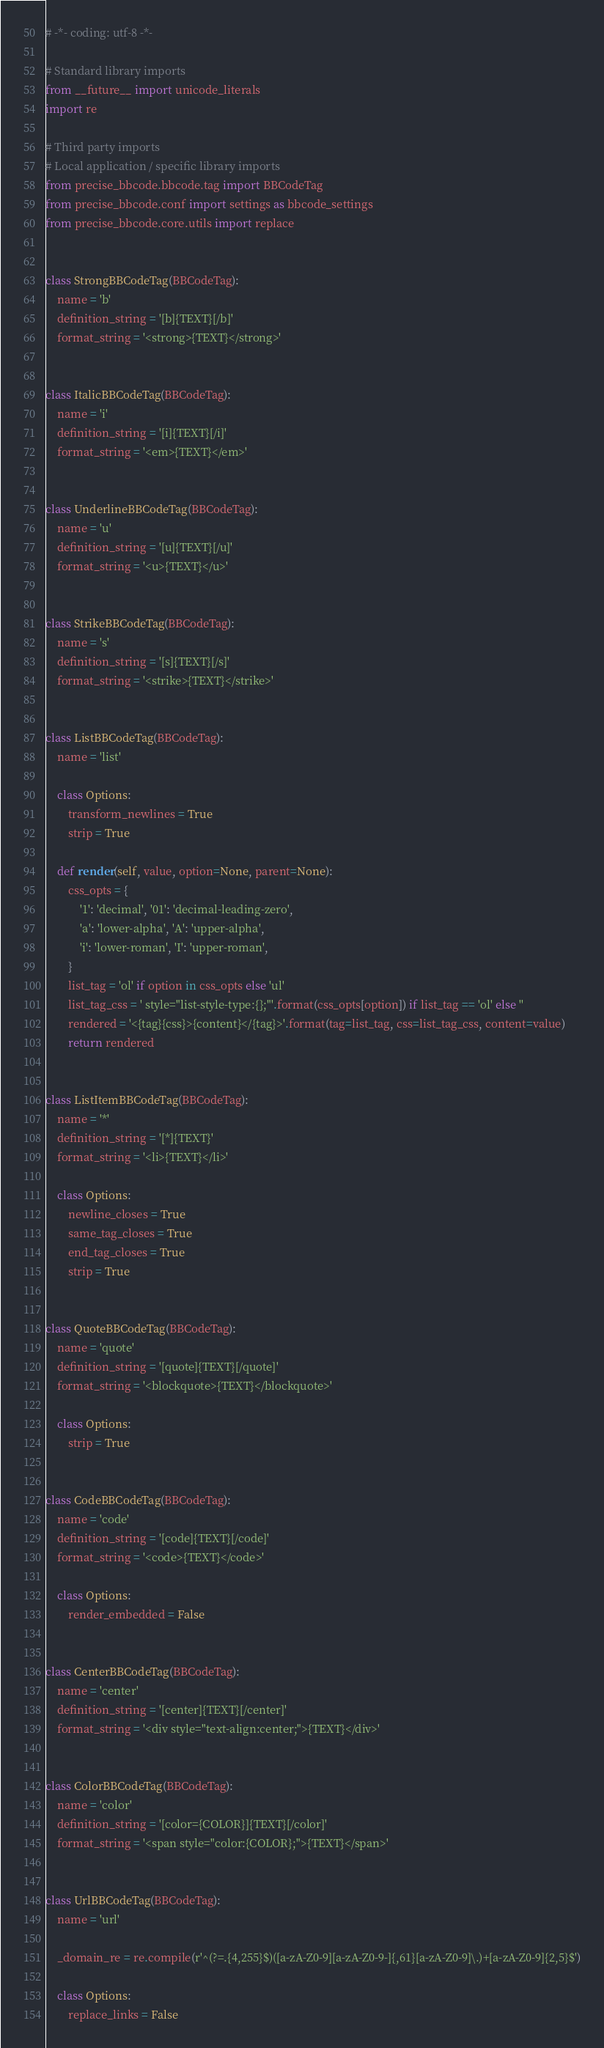<code> <loc_0><loc_0><loc_500><loc_500><_Python_># -*- coding: utf-8 -*-

# Standard library imports
from __future__ import unicode_literals
import re

# Third party imports
# Local application / specific library imports
from precise_bbcode.bbcode.tag import BBCodeTag
from precise_bbcode.conf import settings as bbcode_settings
from precise_bbcode.core.utils import replace


class StrongBBCodeTag(BBCodeTag):
    name = 'b'
    definition_string = '[b]{TEXT}[/b]'
    format_string = '<strong>{TEXT}</strong>'


class ItalicBBCodeTag(BBCodeTag):
    name = 'i'
    definition_string = '[i]{TEXT}[/i]'
    format_string = '<em>{TEXT}</em>'


class UnderlineBBCodeTag(BBCodeTag):
    name = 'u'
    definition_string = '[u]{TEXT}[/u]'
    format_string = '<u>{TEXT}</u>'


class StrikeBBCodeTag(BBCodeTag):
    name = 's'
    definition_string = '[s]{TEXT}[/s]'
    format_string = '<strike>{TEXT}</strike>'


class ListBBCodeTag(BBCodeTag):
    name = 'list'

    class Options:
        transform_newlines = True
        strip = True

    def render(self, value, option=None, parent=None):
        css_opts = {
            '1': 'decimal', '01': 'decimal-leading-zero',
            'a': 'lower-alpha', 'A': 'upper-alpha',
            'i': 'lower-roman', 'I': 'upper-roman',
        }
        list_tag = 'ol' if option in css_opts else 'ul'
        list_tag_css = ' style="list-style-type:{};"'.format(css_opts[option]) if list_tag == 'ol' else ''
        rendered = '<{tag}{css}>{content}</{tag}>'.format(tag=list_tag, css=list_tag_css, content=value)
        return rendered


class ListItemBBCodeTag(BBCodeTag):
    name = '*'
    definition_string = '[*]{TEXT}'
    format_string = '<li>{TEXT}</li>'

    class Options:
        newline_closes = True
        same_tag_closes = True
        end_tag_closes = True
        strip = True


class QuoteBBCodeTag(BBCodeTag):
    name = 'quote'
    definition_string = '[quote]{TEXT}[/quote]'
    format_string = '<blockquote>{TEXT}</blockquote>'

    class Options:
        strip = True


class CodeBBCodeTag(BBCodeTag):
    name = 'code'
    definition_string = '[code]{TEXT}[/code]'
    format_string = '<code>{TEXT}</code>'

    class Options:
        render_embedded = False


class CenterBBCodeTag(BBCodeTag):
    name = 'center'
    definition_string = '[center]{TEXT}[/center]'
    format_string = '<div style="text-align:center;">{TEXT}</div>'


class ColorBBCodeTag(BBCodeTag):
    name = 'color'
    definition_string = '[color={COLOR}]{TEXT}[/color]'
    format_string = '<span style="color:{COLOR};">{TEXT}</span>'


class UrlBBCodeTag(BBCodeTag):
    name = 'url'

    _domain_re = re.compile(r'^(?=.{4,255}$)([a-zA-Z0-9][a-zA-Z0-9-]{,61}[a-zA-Z0-9]\.)+[a-zA-Z0-9]{2,5}$')

    class Options:
        replace_links = False
</code> 